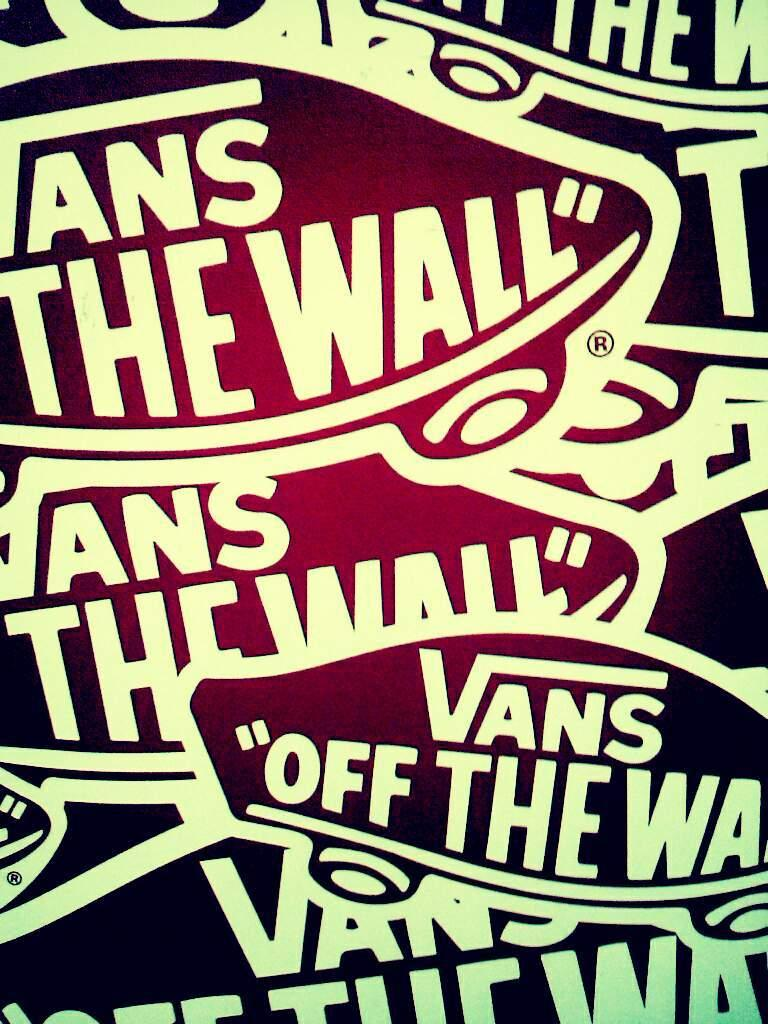<image>
Write a terse but informative summary of the picture. The wall by Vans is written all over the poster. 